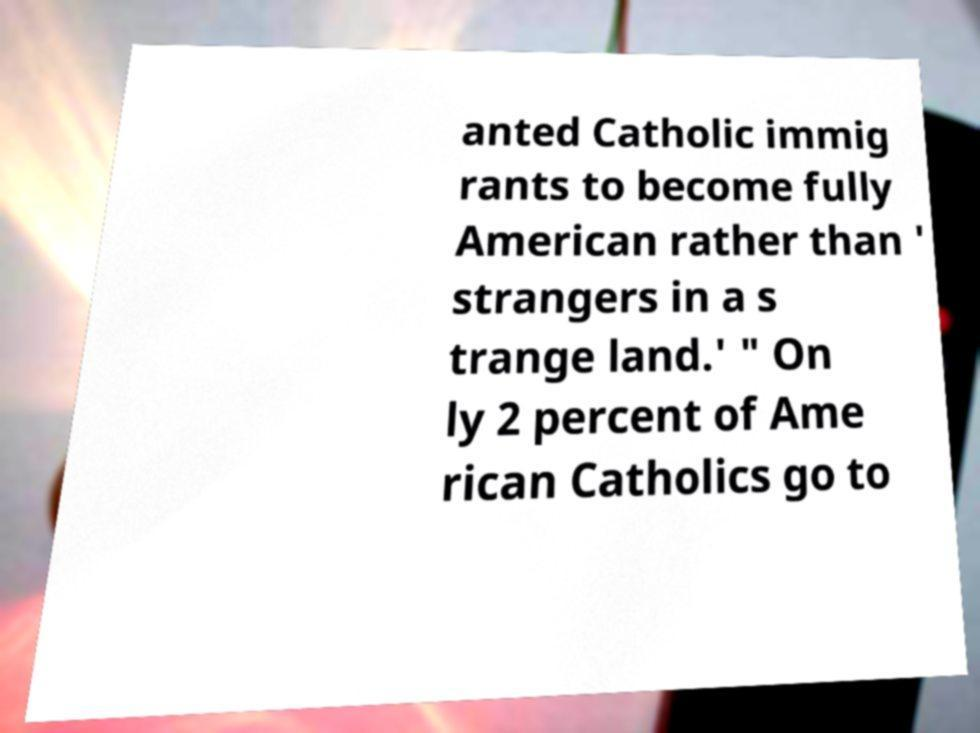Can you accurately transcribe the text from the provided image for me? anted Catholic immig rants to become fully American rather than ' strangers in a s trange land.' " On ly 2 percent of Ame rican Catholics go to 